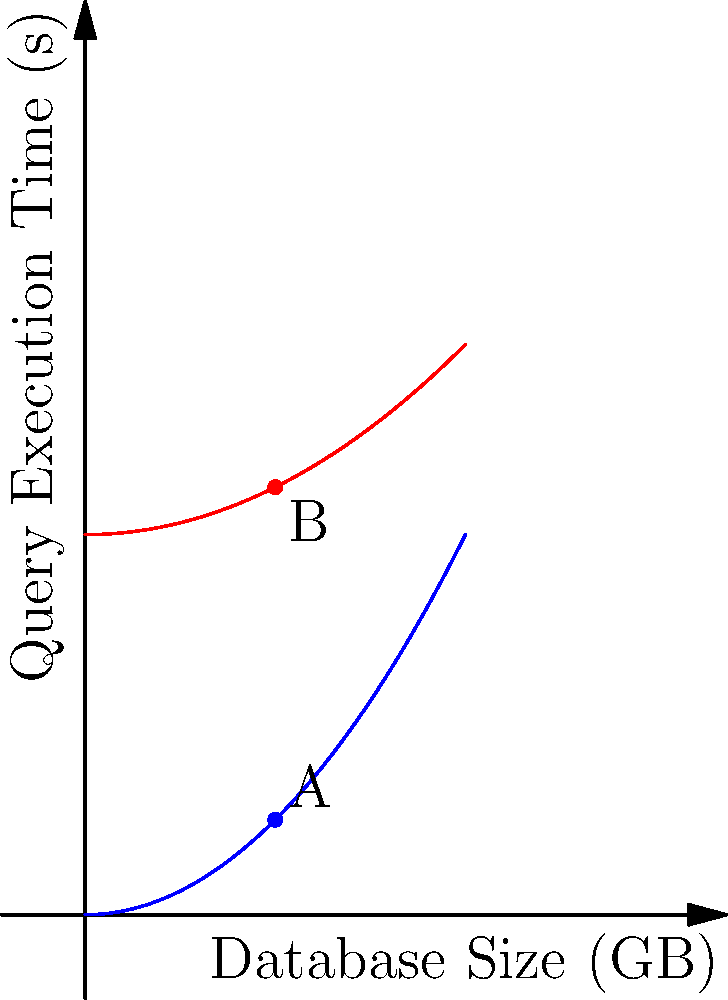In the graph above, two parabolas represent the execution time of an unoptimized and an optimized database query relative to the database size. Point A represents the execution time of the unoptimized query when the database size is 5 GB. If the execution time at point A is 2.5 seconds, what is the approximate execution time (in seconds) of the optimized query for a 10 GB database? Let's approach this step-by-step:

1) First, we need to determine the equation of the unoptimized query parabola:
   - We know that when x = 5 (5 GB), y = 2.5 (2.5 seconds)
   - The general form of a parabola is $y = ax^2$
   - Substituting our known point: $2.5 = a(5^2) = 25a$
   - Solving for a: $a = 2.5/25 = 0.1$
   - So, the equation for the unoptimized query is $y = 0.1x^2$

2) Now, let's look at the optimized query parabola:
   - It appears to have the same shape but is shifted upwards
   - We can represent this as $y = 0.1x^2 + b$, where b is the vertical shift

3) To find b, we can use the fact that at x = 5, the optimized query takes less time:
   - Let's estimate this point to be about 11.25 seconds
   - Substituting: $11.25 = 0.1(5^2) + b = 2.5 + b$
   - Solving for b: $b = 11.25 - 2.5 = 8.75$

4) So, the equation for the optimized query is approximately $y = 0.1x^2 + 8.75$

5) Now, we can find the execution time for a 10 GB database:
   $y = 0.1(10^2) + 8.75 = 0.1(100) + 8.75 = 10 + 8.75 = 18.75$

Therefore, the approximate execution time for the optimized query on a 10 GB database is 18.75 seconds.
Answer: 18.75 seconds 